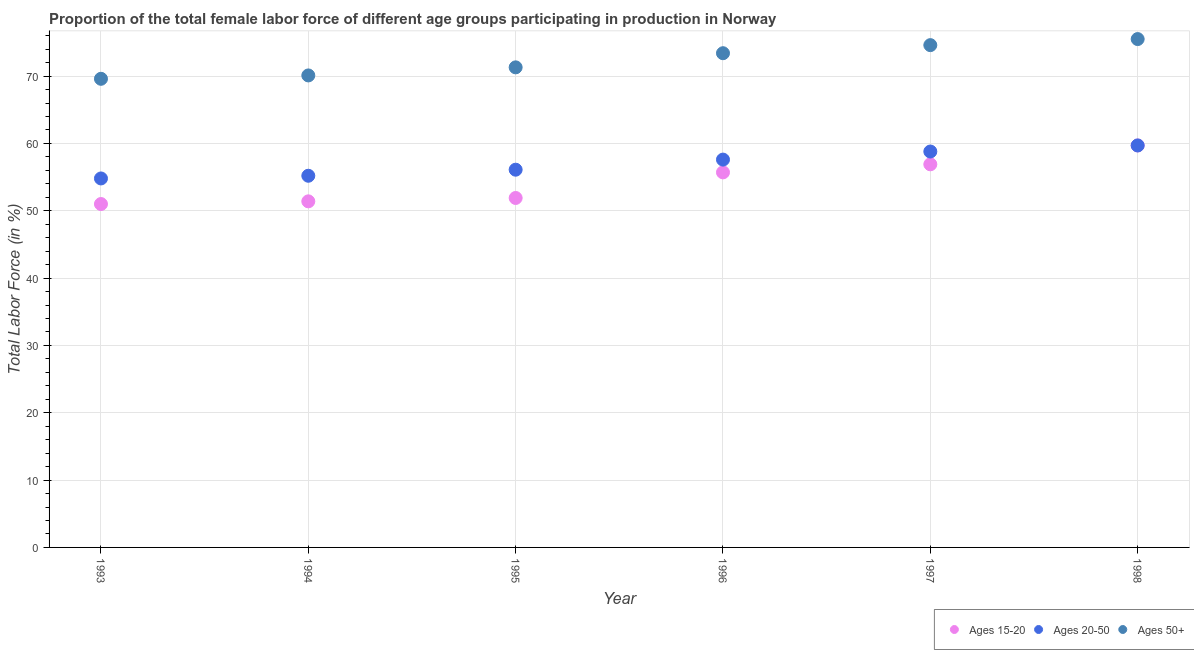Is the number of dotlines equal to the number of legend labels?
Offer a terse response. Yes. What is the percentage of female labor force within the age group 15-20 in 1995?
Offer a terse response. 51.9. Across all years, what is the maximum percentage of female labor force above age 50?
Your response must be concise. 75.5. Across all years, what is the minimum percentage of female labor force above age 50?
Your answer should be very brief. 69.6. In which year was the percentage of female labor force within the age group 20-50 maximum?
Make the answer very short. 1998. What is the total percentage of female labor force within the age group 15-20 in the graph?
Provide a short and direct response. 326.6. What is the difference between the percentage of female labor force within the age group 20-50 in 1996 and that in 1998?
Offer a very short reply. -2.1. What is the difference between the percentage of female labor force within the age group 15-20 in 1997 and the percentage of female labor force within the age group 20-50 in 1996?
Your response must be concise. -0.7. What is the average percentage of female labor force within the age group 20-50 per year?
Provide a short and direct response. 57.03. In the year 1993, what is the difference between the percentage of female labor force within the age group 15-20 and percentage of female labor force within the age group 20-50?
Keep it short and to the point. -3.8. In how many years, is the percentage of female labor force within the age group 20-50 greater than 38 %?
Provide a short and direct response. 6. What is the ratio of the percentage of female labor force within the age group 20-50 in 1994 to that in 1995?
Provide a succinct answer. 0.98. Is the difference between the percentage of female labor force above age 50 in 1995 and 1998 greater than the difference between the percentage of female labor force within the age group 20-50 in 1995 and 1998?
Give a very brief answer. No. What is the difference between the highest and the second highest percentage of female labor force within the age group 15-20?
Your response must be concise. 2.8. What is the difference between the highest and the lowest percentage of female labor force within the age group 20-50?
Offer a very short reply. 4.9. In how many years, is the percentage of female labor force within the age group 20-50 greater than the average percentage of female labor force within the age group 20-50 taken over all years?
Provide a succinct answer. 3. Is it the case that in every year, the sum of the percentage of female labor force within the age group 15-20 and percentage of female labor force within the age group 20-50 is greater than the percentage of female labor force above age 50?
Your answer should be compact. Yes. Does the percentage of female labor force above age 50 monotonically increase over the years?
Your answer should be very brief. Yes. Is the percentage of female labor force within the age group 20-50 strictly greater than the percentage of female labor force above age 50 over the years?
Keep it short and to the point. No. How many years are there in the graph?
Ensure brevity in your answer.  6. What is the difference between two consecutive major ticks on the Y-axis?
Make the answer very short. 10. Does the graph contain any zero values?
Provide a succinct answer. No. Does the graph contain grids?
Provide a succinct answer. Yes. How many legend labels are there?
Your answer should be compact. 3. How are the legend labels stacked?
Make the answer very short. Horizontal. What is the title of the graph?
Your response must be concise. Proportion of the total female labor force of different age groups participating in production in Norway. Does "Machinery" appear as one of the legend labels in the graph?
Keep it short and to the point. No. What is the label or title of the X-axis?
Your answer should be very brief. Year. What is the label or title of the Y-axis?
Your response must be concise. Total Labor Force (in %). What is the Total Labor Force (in %) in Ages 20-50 in 1993?
Provide a short and direct response. 54.8. What is the Total Labor Force (in %) of Ages 50+ in 1993?
Give a very brief answer. 69.6. What is the Total Labor Force (in %) in Ages 15-20 in 1994?
Keep it short and to the point. 51.4. What is the Total Labor Force (in %) in Ages 20-50 in 1994?
Ensure brevity in your answer.  55.2. What is the Total Labor Force (in %) in Ages 50+ in 1994?
Make the answer very short. 70.1. What is the Total Labor Force (in %) in Ages 15-20 in 1995?
Make the answer very short. 51.9. What is the Total Labor Force (in %) in Ages 20-50 in 1995?
Provide a succinct answer. 56.1. What is the Total Labor Force (in %) of Ages 50+ in 1995?
Give a very brief answer. 71.3. What is the Total Labor Force (in %) in Ages 15-20 in 1996?
Your answer should be very brief. 55.7. What is the Total Labor Force (in %) in Ages 20-50 in 1996?
Provide a succinct answer. 57.6. What is the Total Labor Force (in %) in Ages 50+ in 1996?
Your answer should be very brief. 73.4. What is the Total Labor Force (in %) of Ages 15-20 in 1997?
Give a very brief answer. 56.9. What is the Total Labor Force (in %) of Ages 20-50 in 1997?
Provide a short and direct response. 58.8. What is the Total Labor Force (in %) of Ages 50+ in 1997?
Give a very brief answer. 74.6. What is the Total Labor Force (in %) in Ages 15-20 in 1998?
Offer a terse response. 59.7. What is the Total Labor Force (in %) of Ages 20-50 in 1998?
Provide a succinct answer. 59.7. What is the Total Labor Force (in %) in Ages 50+ in 1998?
Give a very brief answer. 75.5. Across all years, what is the maximum Total Labor Force (in %) of Ages 15-20?
Provide a succinct answer. 59.7. Across all years, what is the maximum Total Labor Force (in %) in Ages 20-50?
Offer a very short reply. 59.7. Across all years, what is the maximum Total Labor Force (in %) of Ages 50+?
Your answer should be compact. 75.5. Across all years, what is the minimum Total Labor Force (in %) of Ages 15-20?
Keep it short and to the point. 51. Across all years, what is the minimum Total Labor Force (in %) of Ages 20-50?
Your response must be concise. 54.8. Across all years, what is the minimum Total Labor Force (in %) of Ages 50+?
Your answer should be compact. 69.6. What is the total Total Labor Force (in %) in Ages 15-20 in the graph?
Your response must be concise. 326.6. What is the total Total Labor Force (in %) in Ages 20-50 in the graph?
Ensure brevity in your answer.  342.2. What is the total Total Labor Force (in %) of Ages 50+ in the graph?
Provide a succinct answer. 434.5. What is the difference between the Total Labor Force (in %) of Ages 20-50 in 1993 and that in 1994?
Make the answer very short. -0.4. What is the difference between the Total Labor Force (in %) in Ages 15-20 in 1993 and that in 1995?
Provide a succinct answer. -0.9. What is the difference between the Total Labor Force (in %) in Ages 20-50 in 1993 and that in 1996?
Make the answer very short. -2.8. What is the difference between the Total Labor Force (in %) of Ages 15-20 in 1993 and that in 1997?
Keep it short and to the point. -5.9. What is the difference between the Total Labor Force (in %) in Ages 20-50 in 1993 and that in 1997?
Make the answer very short. -4. What is the difference between the Total Labor Force (in %) of Ages 50+ in 1993 and that in 1997?
Give a very brief answer. -5. What is the difference between the Total Labor Force (in %) in Ages 15-20 in 1993 and that in 1998?
Offer a very short reply. -8.7. What is the difference between the Total Labor Force (in %) in Ages 50+ in 1993 and that in 1998?
Your response must be concise. -5.9. What is the difference between the Total Labor Force (in %) in Ages 20-50 in 1994 and that in 1995?
Give a very brief answer. -0.9. What is the difference between the Total Labor Force (in %) of Ages 50+ in 1994 and that in 1995?
Offer a terse response. -1.2. What is the difference between the Total Labor Force (in %) in Ages 15-20 in 1994 and that in 1996?
Offer a very short reply. -4.3. What is the difference between the Total Labor Force (in %) in Ages 15-20 in 1994 and that in 1997?
Offer a terse response. -5.5. What is the difference between the Total Labor Force (in %) of Ages 20-50 in 1994 and that in 1997?
Ensure brevity in your answer.  -3.6. What is the difference between the Total Labor Force (in %) of Ages 15-20 in 1994 and that in 1998?
Your answer should be compact. -8.3. What is the difference between the Total Labor Force (in %) of Ages 50+ in 1994 and that in 1998?
Offer a terse response. -5.4. What is the difference between the Total Labor Force (in %) of Ages 50+ in 1995 and that in 1996?
Give a very brief answer. -2.1. What is the difference between the Total Labor Force (in %) of Ages 15-20 in 1995 and that in 1997?
Ensure brevity in your answer.  -5. What is the difference between the Total Labor Force (in %) of Ages 15-20 in 1995 and that in 1998?
Your answer should be compact. -7.8. What is the difference between the Total Labor Force (in %) in Ages 20-50 in 1995 and that in 1998?
Your answer should be compact. -3.6. What is the difference between the Total Labor Force (in %) of Ages 20-50 in 1996 and that in 1998?
Your answer should be compact. -2.1. What is the difference between the Total Labor Force (in %) of Ages 15-20 in 1997 and that in 1998?
Your response must be concise. -2.8. What is the difference between the Total Labor Force (in %) in Ages 20-50 in 1997 and that in 1998?
Your answer should be compact. -0.9. What is the difference between the Total Labor Force (in %) in Ages 50+ in 1997 and that in 1998?
Your answer should be compact. -0.9. What is the difference between the Total Labor Force (in %) in Ages 15-20 in 1993 and the Total Labor Force (in %) in Ages 20-50 in 1994?
Provide a succinct answer. -4.2. What is the difference between the Total Labor Force (in %) of Ages 15-20 in 1993 and the Total Labor Force (in %) of Ages 50+ in 1994?
Provide a succinct answer. -19.1. What is the difference between the Total Labor Force (in %) in Ages 20-50 in 1993 and the Total Labor Force (in %) in Ages 50+ in 1994?
Offer a very short reply. -15.3. What is the difference between the Total Labor Force (in %) of Ages 15-20 in 1993 and the Total Labor Force (in %) of Ages 20-50 in 1995?
Offer a terse response. -5.1. What is the difference between the Total Labor Force (in %) in Ages 15-20 in 1993 and the Total Labor Force (in %) in Ages 50+ in 1995?
Your response must be concise. -20.3. What is the difference between the Total Labor Force (in %) in Ages 20-50 in 1993 and the Total Labor Force (in %) in Ages 50+ in 1995?
Offer a very short reply. -16.5. What is the difference between the Total Labor Force (in %) of Ages 15-20 in 1993 and the Total Labor Force (in %) of Ages 20-50 in 1996?
Ensure brevity in your answer.  -6.6. What is the difference between the Total Labor Force (in %) in Ages 15-20 in 1993 and the Total Labor Force (in %) in Ages 50+ in 1996?
Provide a short and direct response. -22.4. What is the difference between the Total Labor Force (in %) of Ages 20-50 in 1993 and the Total Labor Force (in %) of Ages 50+ in 1996?
Your answer should be compact. -18.6. What is the difference between the Total Labor Force (in %) of Ages 15-20 in 1993 and the Total Labor Force (in %) of Ages 50+ in 1997?
Keep it short and to the point. -23.6. What is the difference between the Total Labor Force (in %) in Ages 20-50 in 1993 and the Total Labor Force (in %) in Ages 50+ in 1997?
Keep it short and to the point. -19.8. What is the difference between the Total Labor Force (in %) of Ages 15-20 in 1993 and the Total Labor Force (in %) of Ages 50+ in 1998?
Offer a terse response. -24.5. What is the difference between the Total Labor Force (in %) in Ages 20-50 in 1993 and the Total Labor Force (in %) in Ages 50+ in 1998?
Make the answer very short. -20.7. What is the difference between the Total Labor Force (in %) in Ages 15-20 in 1994 and the Total Labor Force (in %) in Ages 50+ in 1995?
Provide a succinct answer. -19.9. What is the difference between the Total Labor Force (in %) of Ages 20-50 in 1994 and the Total Labor Force (in %) of Ages 50+ in 1995?
Keep it short and to the point. -16.1. What is the difference between the Total Labor Force (in %) in Ages 15-20 in 1994 and the Total Labor Force (in %) in Ages 20-50 in 1996?
Your response must be concise. -6.2. What is the difference between the Total Labor Force (in %) of Ages 15-20 in 1994 and the Total Labor Force (in %) of Ages 50+ in 1996?
Make the answer very short. -22. What is the difference between the Total Labor Force (in %) of Ages 20-50 in 1994 and the Total Labor Force (in %) of Ages 50+ in 1996?
Give a very brief answer. -18.2. What is the difference between the Total Labor Force (in %) in Ages 15-20 in 1994 and the Total Labor Force (in %) in Ages 50+ in 1997?
Your response must be concise. -23.2. What is the difference between the Total Labor Force (in %) in Ages 20-50 in 1994 and the Total Labor Force (in %) in Ages 50+ in 1997?
Make the answer very short. -19.4. What is the difference between the Total Labor Force (in %) in Ages 15-20 in 1994 and the Total Labor Force (in %) in Ages 20-50 in 1998?
Your response must be concise. -8.3. What is the difference between the Total Labor Force (in %) of Ages 15-20 in 1994 and the Total Labor Force (in %) of Ages 50+ in 1998?
Provide a short and direct response. -24.1. What is the difference between the Total Labor Force (in %) in Ages 20-50 in 1994 and the Total Labor Force (in %) in Ages 50+ in 1998?
Your answer should be compact. -20.3. What is the difference between the Total Labor Force (in %) in Ages 15-20 in 1995 and the Total Labor Force (in %) in Ages 20-50 in 1996?
Offer a terse response. -5.7. What is the difference between the Total Labor Force (in %) in Ages 15-20 in 1995 and the Total Labor Force (in %) in Ages 50+ in 1996?
Your answer should be very brief. -21.5. What is the difference between the Total Labor Force (in %) in Ages 20-50 in 1995 and the Total Labor Force (in %) in Ages 50+ in 1996?
Your answer should be very brief. -17.3. What is the difference between the Total Labor Force (in %) of Ages 15-20 in 1995 and the Total Labor Force (in %) of Ages 20-50 in 1997?
Make the answer very short. -6.9. What is the difference between the Total Labor Force (in %) in Ages 15-20 in 1995 and the Total Labor Force (in %) in Ages 50+ in 1997?
Give a very brief answer. -22.7. What is the difference between the Total Labor Force (in %) of Ages 20-50 in 1995 and the Total Labor Force (in %) of Ages 50+ in 1997?
Make the answer very short. -18.5. What is the difference between the Total Labor Force (in %) of Ages 15-20 in 1995 and the Total Labor Force (in %) of Ages 20-50 in 1998?
Offer a very short reply. -7.8. What is the difference between the Total Labor Force (in %) in Ages 15-20 in 1995 and the Total Labor Force (in %) in Ages 50+ in 1998?
Keep it short and to the point. -23.6. What is the difference between the Total Labor Force (in %) of Ages 20-50 in 1995 and the Total Labor Force (in %) of Ages 50+ in 1998?
Make the answer very short. -19.4. What is the difference between the Total Labor Force (in %) of Ages 15-20 in 1996 and the Total Labor Force (in %) of Ages 20-50 in 1997?
Offer a terse response. -3.1. What is the difference between the Total Labor Force (in %) of Ages 15-20 in 1996 and the Total Labor Force (in %) of Ages 50+ in 1997?
Ensure brevity in your answer.  -18.9. What is the difference between the Total Labor Force (in %) in Ages 20-50 in 1996 and the Total Labor Force (in %) in Ages 50+ in 1997?
Offer a terse response. -17. What is the difference between the Total Labor Force (in %) of Ages 15-20 in 1996 and the Total Labor Force (in %) of Ages 20-50 in 1998?
Make the answer very short. -4. What is the difference between the Total Labor Force (in %) in Ages 15-20 in 1996 and the Total Labor Force (in %) in Ages 50+ in 1998?
Make the answer very short. -19.8. What is the difference between the Total Labor Force (in %) in Ages 20-50 in 1996 and the Total Labor Force (in %) in Ages 50+ in 1998?
Your response must be concise. -17.9. What is the difference between the Total Labor Force (in %) in Ages 15-20 in 1997 and the Total Labor Force (in %) in Ages 50+ in 1998?
Your answer should be compact. -18.6. What is the difference between the Total Labor Force (in %) of Ages 20-50 in 1997 and the Total Labor Force (in %) of Ages 50+ in 1998?
Your answer should be compact. -16.7. What is the average Total Labor Force (in %) of Ages 15-20 per year?
Your answer should be compact. 54.43. What is the average Total Labor Force (in %) in Ages 20-50 per year?
Give a very brief answer. 57.03. What is the average Total Labor Force (in %) of Ages 50+ per year?
Offer a terse response. 72.42. In the year 1993, what is the difference between the Total Labor Force (in %) of Ages 15-20 and Total Labor Force (in %) of Ages 50+?
Your answer should be very brief. -18.6. In the year 1993, what is the difference between the Total Labor Force (in %) in Ages 20-50 and Total Labor Force (in %) in Ages 50+?
Provide a succinct answer. -14.8. In the year 1994, what is the difference between the Total Labor Force (in %) in Ages 15-20 and Total Labor Force (in %) in Ages 50+?
Offer a terse response. -18.7. In the year 1994, what is the difference between the Total Labor Force (in %) in Ages 20-50 and Total Labor Force (in %) in Ages 50+?
Offer a very short reply. -14.9. In the year 1995, what is the difference between the Total Labor Force (in %) of Ages 15-20 and Total Labor Force (in %) of Ages 50+?
Give a very brief answer. -19.4. In the year 1995, what is the difference between the Total Labor Force (in %) in Ages 20-50 and Total Labor Force (in %) in Ages 50+?
Your answer should be compact. -15.2. In the year 1996, what is the difference between the Total Labor Force (in %) of Ages 15-20 and Total Labor Force (in %) of Ages 20-50?
Keep it short and to the point. -1.9. In the year 1996, what is the difference between the Total Labor Force (in %) in Ages 15-20 and Total Labor Force (in %) in Ages 50+?
Provide a short and direct response. -17.7. In the year 1996, what is the difference between the Total Labor Force (in %) in Ages 20-50 and Total Labor Force (in %) in Ages 50+?
Provide a succinct answer. -15.8. In the year 1997, what is the difference between the Total Labor Force (in %) of Ages 15-20 and Total Labor Force (in %) of Ages 50+?
Make the answer very short. -17.7. In the year 1997, what is the difference between the Total Labor Force (in %) of Ages 20-50 and Total Labor Force (in %) of Ages 50+?
Your response must be concise. -15.8. In the year 1998, what is the difference between the Total Labor Force (in %) of Ages 15-20 and Total Labor Force (in %) of Ages 20-50?
Your response must be concise. 0. In the year 1998, what is the difference between the Total Labor Force (in %) of Ages 15-20 and Total Labor Force (in %) of Ages 50+?
Keep it short and to the point. -15.8. In the year 1998, what is the difference between the Total Labor Force (in %) of Ages 20-50 and Total Labor Force (in %) of Ages 50+?
Give a very brief answer. -15.8. What is the ratio of the Total Labor Force (in %) of Ages 50+ in 1993 to that in 1994?
Your answer should be very brief. 0.99. What is the ratio of the Total Labor Force (in %) of Ages 15-20 in 1993 to that in 1995?
Offer a terse response. 0.98. What is the ratio of the Total Labor Force (in %) in Ages 20-50 in 1993 to that in 1995?
Keep it short and to the point. 0.98. What is the ratio of the Total Labor Force (in %) in Ages 50+ in 1993 to that in 1995?
Your answer should be very brief. 0.98. What is the ratio of the Total Labor Force (in %) of Ages 15-20 in 1993 to that in 1996?
Your response must be concise. 0.92. What is the ratio of the Total Labor Force (in %) of Ages 20-50 in 1993 to that in 1996?
Offer a terse response. 0.95. What is the ratio of the Total Labor Force (in %) of Ages 50+ in 1993 to that in 1996?
Your response must be concise. 0.95. What is the ratio of the Total Labor Force (in %) of Ages 15-20 in 1993 to that in 1997?
Ensure brevity in your answer.  0.9. What is the ratio of the Total Labor Force (in %) of Ages 20-50 in 1993 to that in 1997?
Provide a short and direct response. 0.93. What is the ratio of the Total Labor Force (in %) in Ages 50+ in 1993 to that in 1997?
Ensure brevity in your answer.  0.93. What is the ratio of the Total Labor Force (in %) of Ages 15-20 in 1993 to that in 1998?
Give a very brief answer. 0.85. What is the ratio of the Total Labor Force (in %) of Ages 20-50 in 1993 to that in 1998?
Your response must be concise. 0.92. What is the ratio of the Total Labor Force (in %) of Ages 50+ in 1993 to that in 1998?
Provide a succinct answer. 0.92. What is the ratio of the Total Labor Force (in %) of Ages 15-20 in 1994 to that in 1995?
Your answer should be compact. 0.99. What is the ratio of the Total Labor Force (in %) of Ages 50+ in 1994 to that in 1995?
Keep it short and to the point. 0.98. What is the ratio of the Total Labor Force (in %) of Ages 15-20 in 1994 to that in 1996?
Your answer should be very brief. 0.92. What is the ratio of the Total Labor Force (in %) in Ages 20-50 in 1994 to that in 1996?
Your answer should be compact. 0.96. What is the ratio of the Total Labor Force (in %) in Ages 50+ in 1994 to that in 1996?
Give a very brief answer. 0.95. What is the ratio of the Total Labor Force (in %) of Ages 15-20 in 1994 to that in 1997?
Offer a very short reply. 0.9. What is the ratio of the Total Labor Force (in %) of Ages 20-50 in 1994 to that in 1997?
Your answer should be compact. 0.94. What is the ratio of the Total Labor Force (in %) in Ages 50+ in 1994 to that in 1997?
Your answer should be very brief. 0.94. What is the ratio of the Total Labor Force (in %) of Ages 15-20 in 1994 to that in 1998?
Your response must be concise. 0.86. What is the ratio of the Total Labor Force (in %) in Ages 20-50 in 1994 to that in 1998?
Make the answer very short. 0.92. What is the ratio of the Total Labor Force (in %) of Ages 50+ in 1994 to that in 1998?
Ensure brevity in your answer.  0.93. What is the ratio of the Total Labor Force (in %) of Ages 15-20 in 1995 to that in 1996?
Your response must be concise. 0.93. What is the ratio of the Total Labor Force (in %) in Ages 20-50 in 1995 to that in 1996?
Your response must be concise. 0.97. What is the ratio of the Total Labor Force (in %) of Ages 50+ in 1995 to that in 1996?
Offer a terse response. 0.97. What is the ratio of the Total Labor Force (in %) in Ages 15-20 in 1995 to that in 1997?
Keep it short and to the point. 0.91. What is the ratio of the Total Labor Force (in %) of Ages 20-50 in 1995 to that in 1997?
Give a very brief answer. 0.95. What is the ratio of the Total Labor Force (in %) in Ages 50+ in 1995 to that in 1997?
Your answer should be very brief. 0.96. What is the ratio of the Total Labor Force (in %) of Ages 15-20 in 1995 to that in 1998?
Your answer should be compact. 0.87. What is the ratio of the Total Labor Force (in %) in Ages 20-50 in 1995 to that in 1998?
Give a very brief answer. 0.94. What is the ratio of the Total Labor Force (in %) of Ages 15-20 in 1996 to that in 1997?
Keep it short and to the point. 0.98. What is the ratio of the Total Labor Force (in %) of Ages 20-50 in 1996 to that in 1997?
Your answer should be very brief. 0.98. What is the ratio of the Total Labor Force (in %) of Ages 50+ in 1996 to that in 1997?
Your response must be concise. 0.98. What is the ratio of the Total Labor Force (in %) of Ages 15-20 in 1996 to that in 1998?
Your answer should be very brief. 0.93. What is the ratio of the Total Labor Force (in %) in Ages 20-50 in 1996 to that in 1998?
Provide a succinct answer. 0.96. What is the ratio of the Total Labor Force (in %) in Ages 50+ in 1996 to that in 1998?
Offer a very short reply. 0.97. What is the ratio of the Total Labor Force (in %) of Ages 15-20 in 1997 to that in 1998?
Your answer should be compact. 0.95. What is the ratio of the Total Labor Force (in %) of Ages 20-50 in 1997 to that in 1998?
Your answer should be very brief. 0.98. What is the ratio of the Total Labor Force (in %) in Ages 50+ in 1997 to that in 1998?
Offer a very short reply. 0.99. What is the difference between the highest and the second highest Total Labor Force (in %) in Ages 15-20?
Make the answer very short. 2.8. 